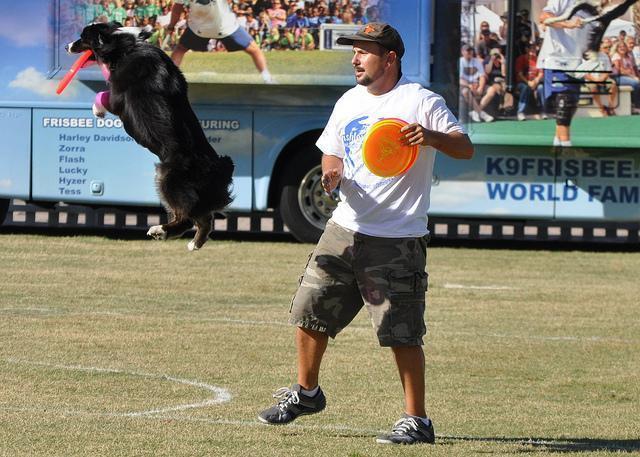How many people are visible?
Give a very brief answer. 3. How many frisbees are in the picture?
Give a very brief answer. 1. How many sandwiches are on the plate?
Give a very brief answer. 0. 